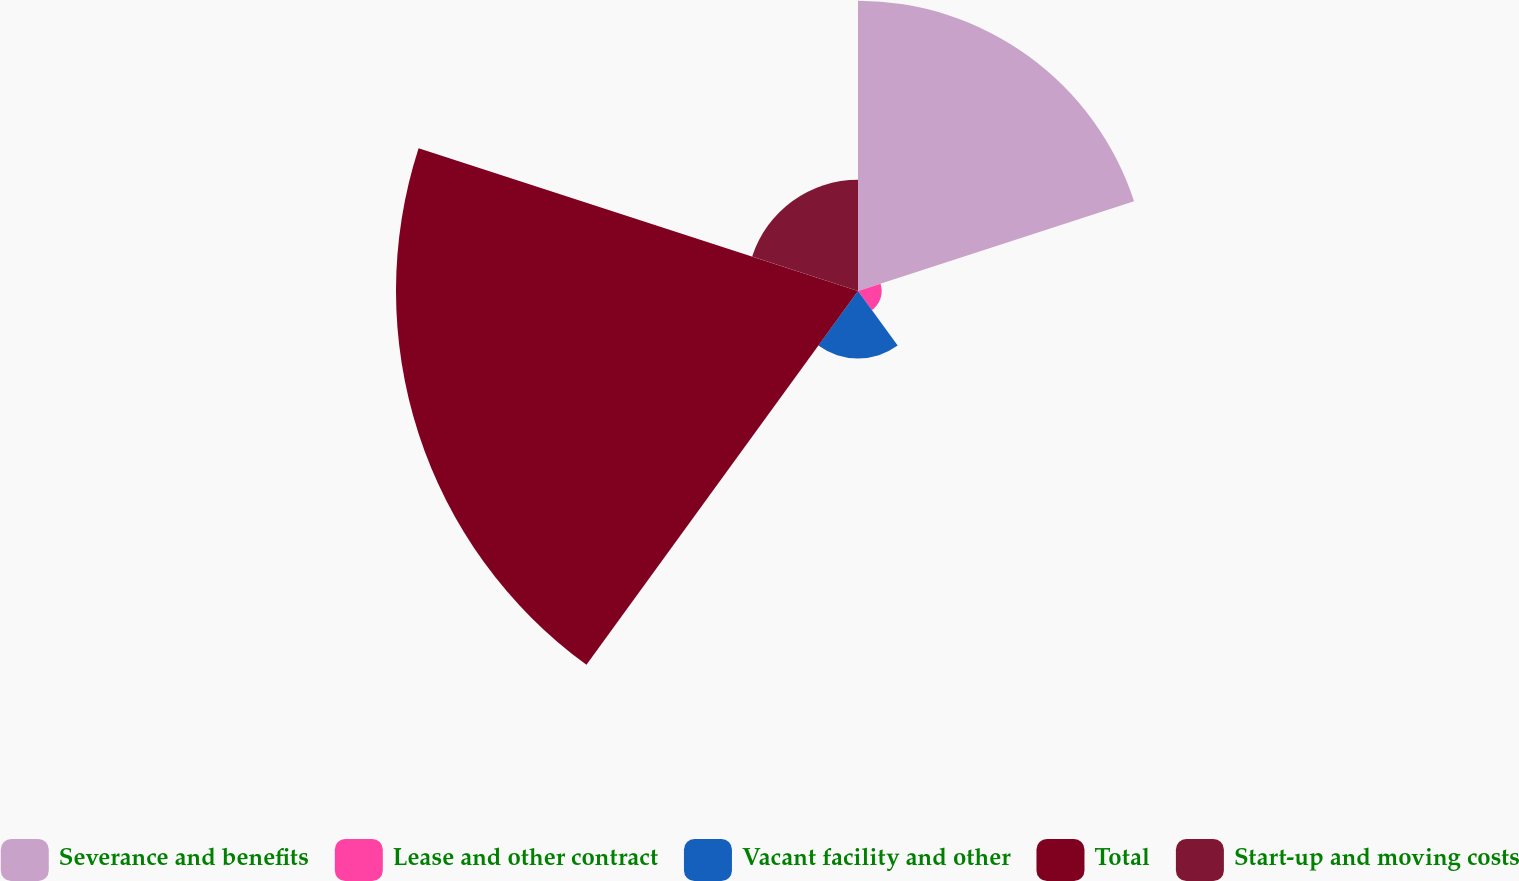Convert chart. <chart><loc_0><loc_0><loc_500><loc_500><pie_chart><fcel>Severance and benefits<fcel>Lease and other contract<fcel>Vacant facility and other<fcel>Total<fcel>Start-up and moving costs<nl><fcel>30.4%<fcel>2.48%<fcel>7.07%<fcel>48.39%<fcel>11.66%<nl></chart> 